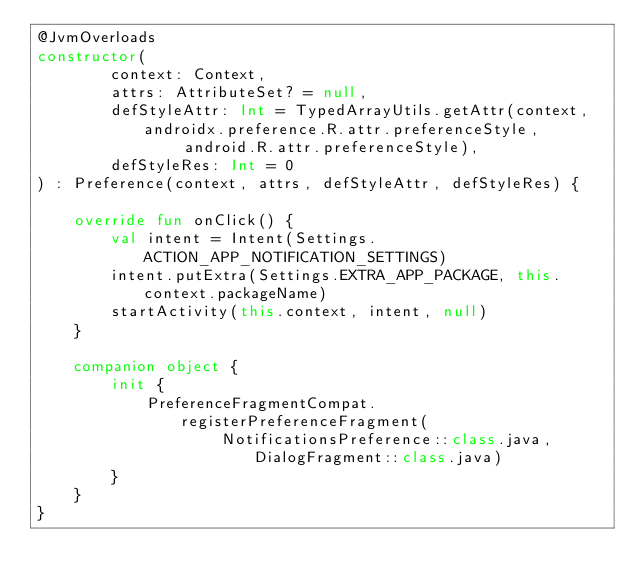<code> <loc_0><loc_0><loc_500><loc_500><_Kotlin_>@JvmOverloads
constructor(
        context: Context,
        attrs: AttributeSet? = null,
        defStyleAttr: Int = TypedArrayUtils.getAttr(context, androidx.preference.R.attr.preferenceStyle,
                android.R.attr.preferenceStyle),
        defStyleRes: Int = 0
) : Preference(context, attrs, defStyleAttr, defStyleRes) {

    override fun onClick() {
        val intent = Intent(Settings.ACTION_APP_NOTIFICATION_SETTINGS)
        intent.putExtra(Settings.EXTRA_APP_PACKAGE, this.context.packageName)
        startActivity(this.context, intent, null)
    }

    companion object {
        init {
            PreferenceFragmentCompat.registerPreferenceFragment(
                    NotificationsPreference::class.java, DialogFragment::class.java)
        }
    }
}
</code> 